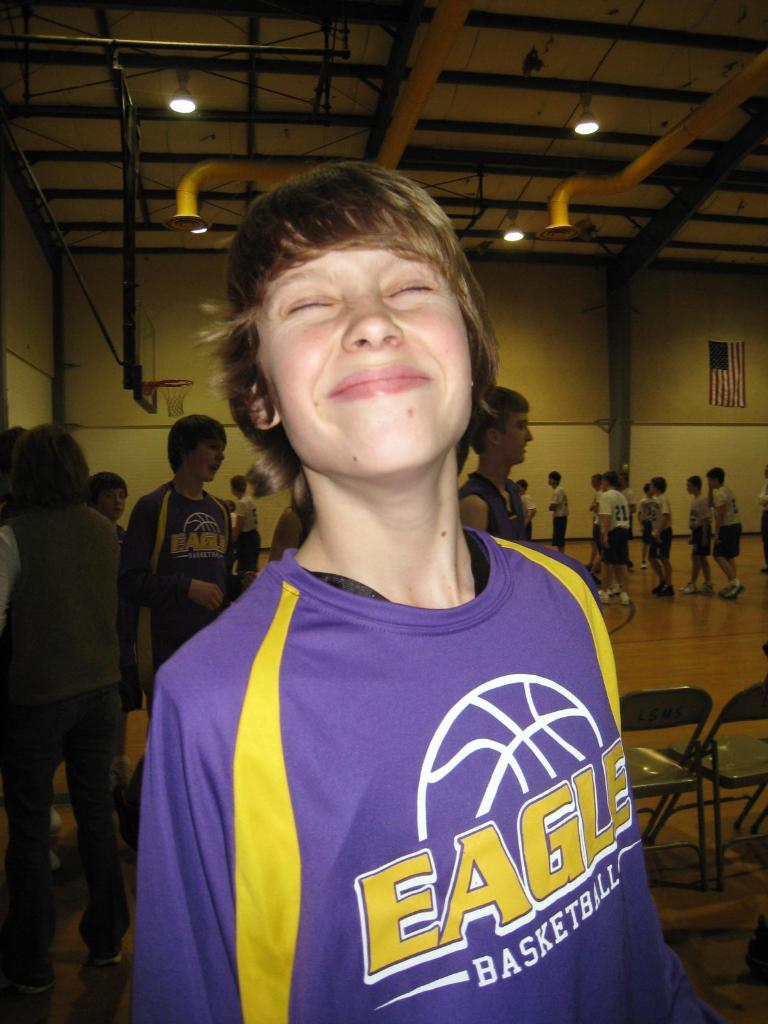<image>
Relay a brief, clear account of the picture shown. Boy wearing a purple shirt that has the word EAGLE on it. 